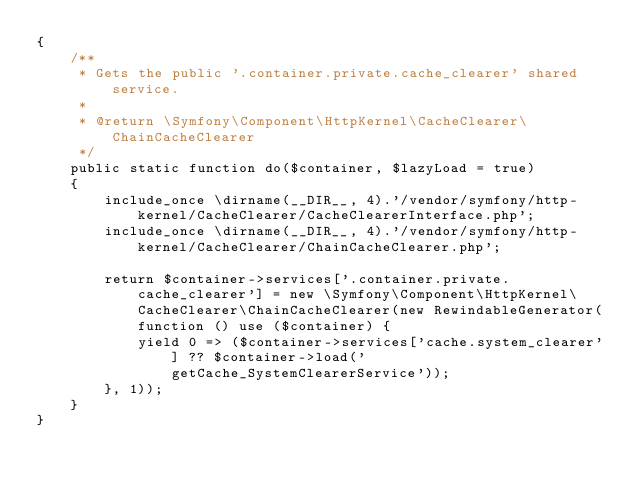<code> <loc_0><loc_0><loc_500><loc_500><_PHP_>{
    /**
     * Gets the public '.container.private.cache_clearer' shared service.
     *
     * @return \Symfony\Component\HttpKernel\CacheClearer\ChainCacheClearer
     */
    public static function do($container, $lazyLoad = true)
    {
        include_once \dirname(__DIR__, 4).'/vendor/symfony/http-kernel/CacheClearer/CacheClearerInterface.php';
        include_once \dirname(__DIR__, 4).'/vendor/symfony/http-kernel/CacheClearer/ChainCacheClearer.php';

        return $container->services['.container.private.cache_clearer'] = new \Symfony\Component\HttpKernel\CacheClearer\ChainCacheClearer(new RewindableGenerator(function () use ($container) {
            yield 0 => ($container->services['cache.system_clearer'] ?? $container->load('getCache_SystemClearerService'));
        }, 1));
    }
}
</code> 